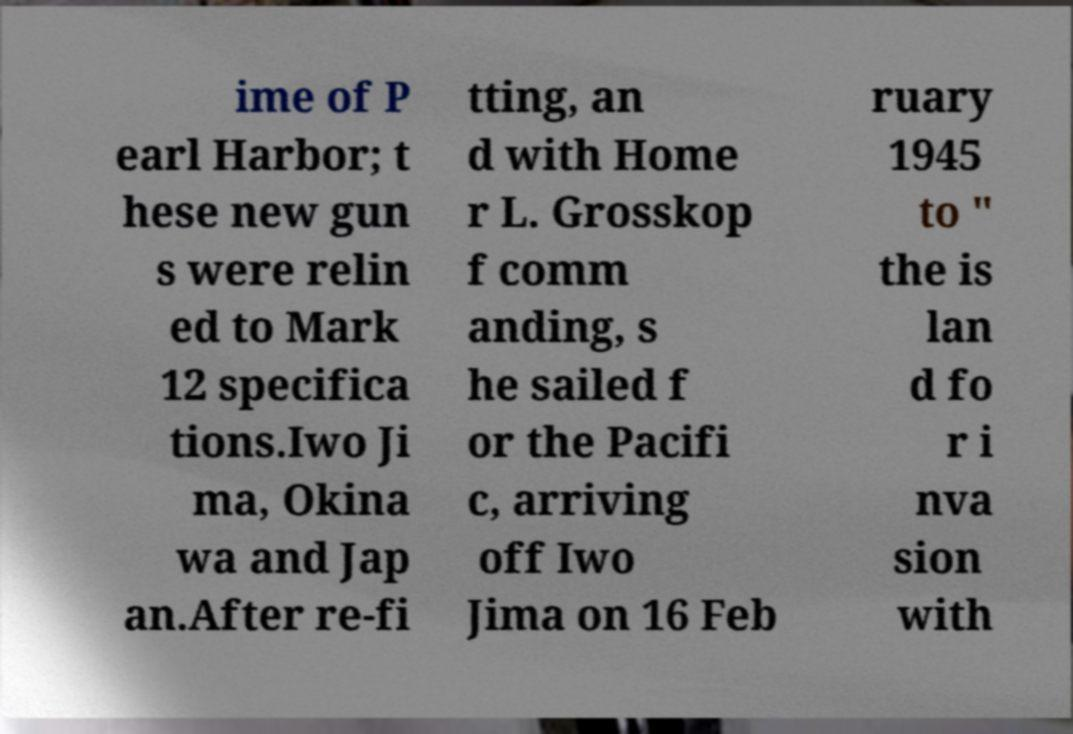Can you accurately transcribe the text from the provided image for me? ime of P earl Harbor; t hese new gun s were relin ed to Mark 12 specifica tions.Iwo Ji ma, Okina wa and Jap an.After re-fi tting, an d with Home r L. Grosskop f comm anding, s he sailed f or the Pacifi c, arriving off Iwo Jima on 16 Feb ruary 1945 to " the is lan d fo r i nva sion with 